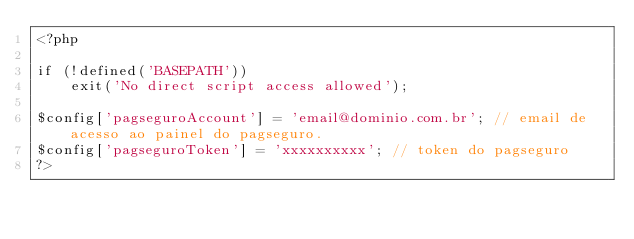Convert code to text. <code><loc_0><loc_0><loc_500><loc_500><_PHP_><?php

if (!defined('BASEPATH'))
    exit('No direct script access allowed');

$config['pagseguroAccount'] = 'email@dominio.com.br'; // email de acesso ao painel do pagseguro.
$config['pagseguroToken'] = 'xxxxxxxxxx'; // token do pagseguro
?></code> 